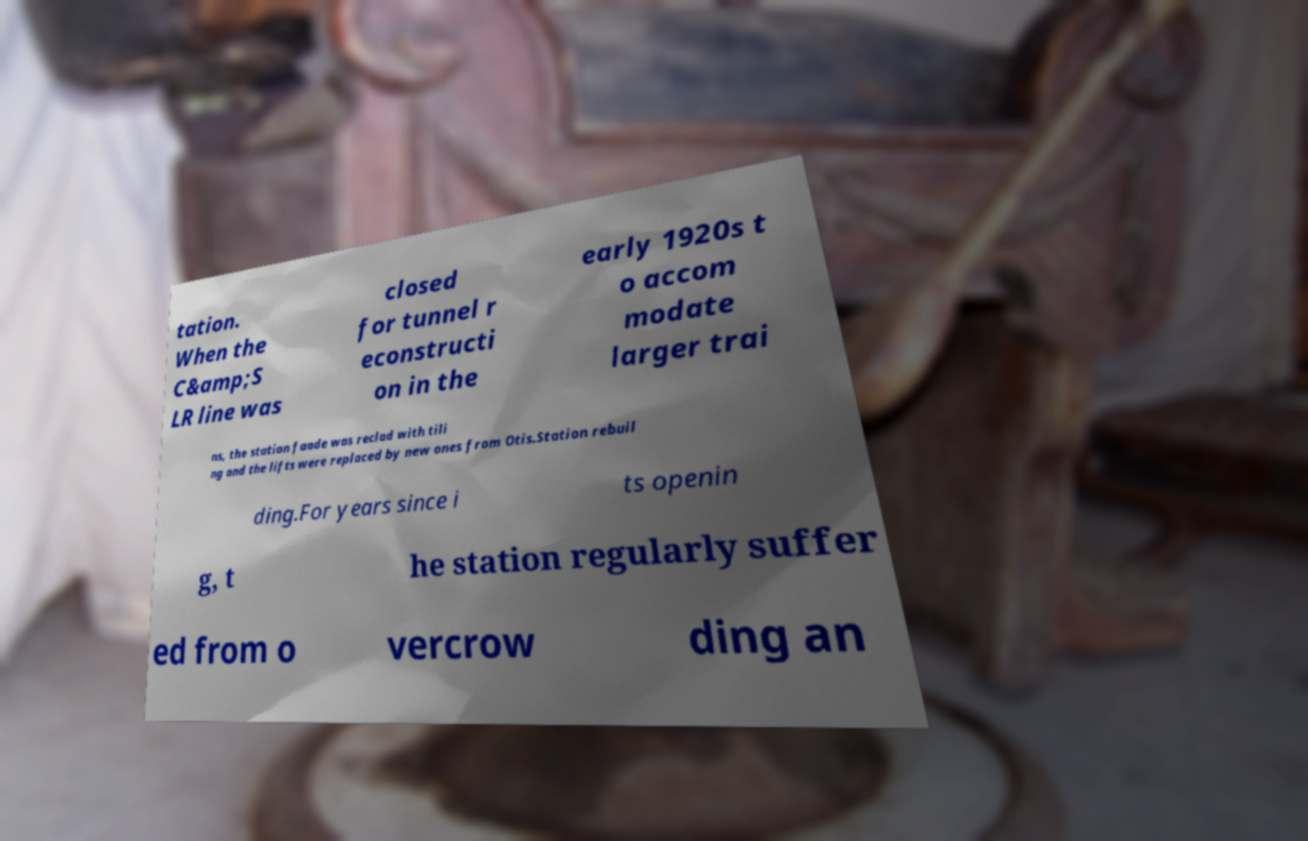For documentation purposes, I need the text within this image transcribed. Could you provide that? tation. When the C&amp;S LR line was closed for tunnel r econstructi on in the early 1920s t o accom modate larger trai ns, the station faade was reclad with tili ng and the lifts were replaced by new ones from Otis.Station rebuil ding.For years since i ts openin g, t he station regularly suffer ed from o vercrow ding an 